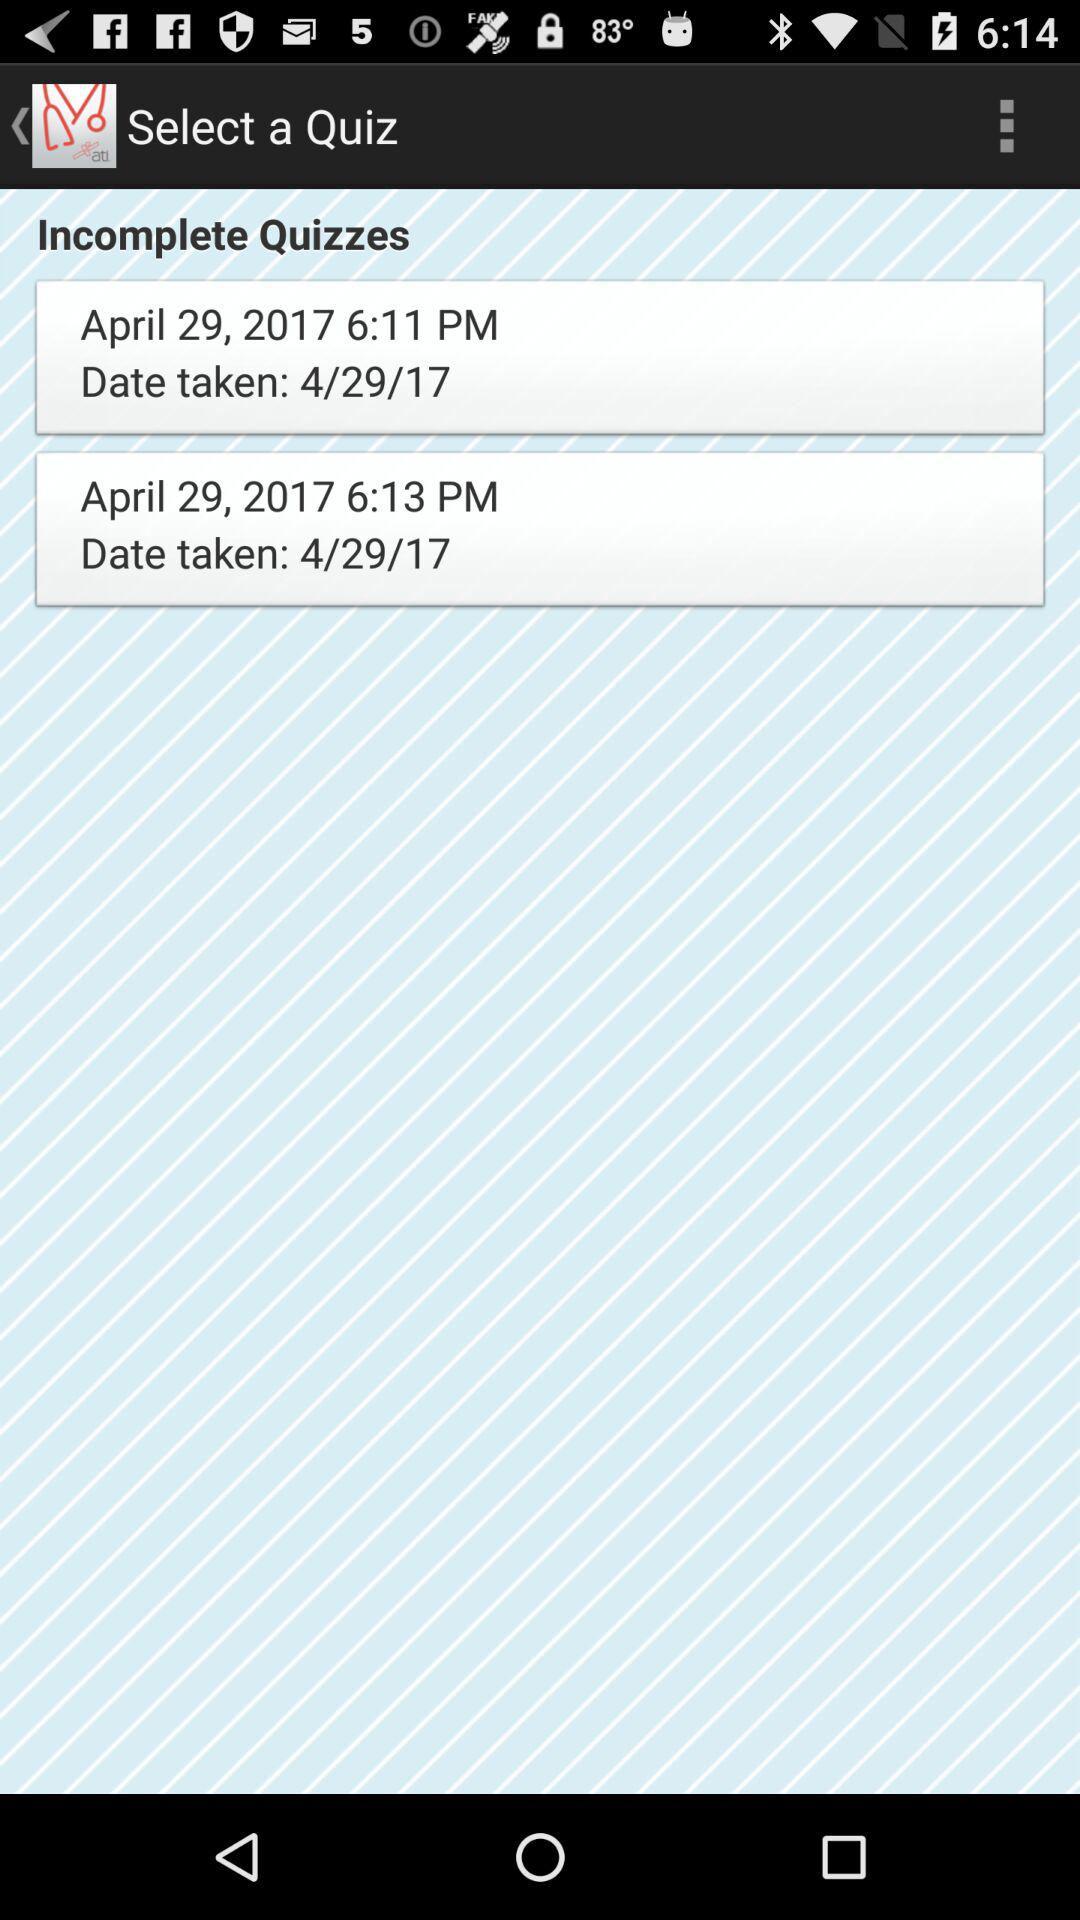What is the difference in the time of the two incomplete quizzes?
Answer the question using a single word or phrase. 2 minutes 